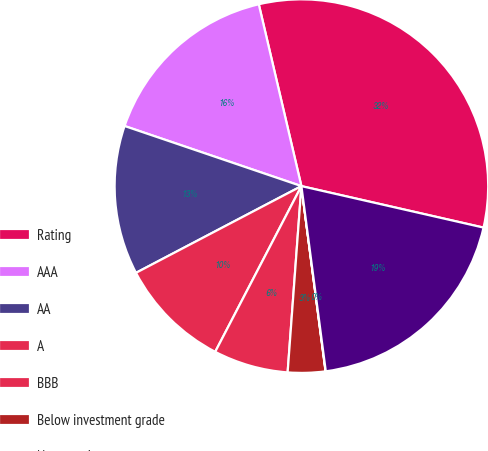Convert chart. <chart><loc_0><loc_0><loc_500><loc_500><pie_chart><fcel>Rating<fcel>AAA<fcel>AA<fcel>A<fcel>BBB<fcel>Below investment grade<fcel>Non-rated<fcel>Total<nl><fcel>32.23%<fcel>16.12%<fcel>12.9%<fcel>9.68%<fcel>6.46%<fcel>3.24%<fcel>0.02%<fcel>19.35%<nl></chart> 